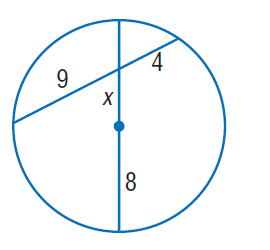Question: Find x. Round to the nearest tenth, if necessary.
Choices:
A. 2.7
B. 3
C. 4
D. 5.3
Answer with the letter. Answer: D 